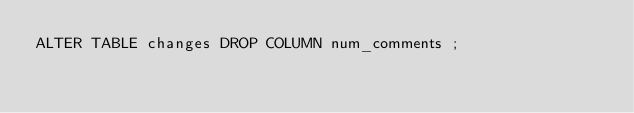<code> <loc_0><loc_0><loc_500><loc_500><_SQL_>ALTER TABLE changes DROP COLUMN num_comments ;</code> 